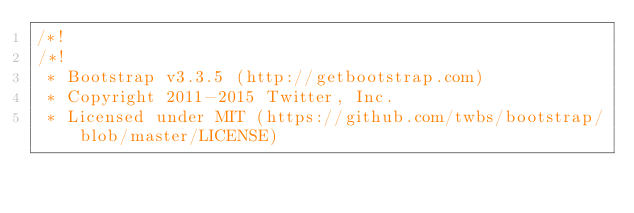<code> <loc_0><loc_0><loc_500><loc_500><_CSS_>/*!
/*!
 * Bootstrap v3.3.5 (http://getbootstrap.com)
 * Copyright 2011-2015 Twitter, Inc.
 * Licensed under MIT (https://github.com/twbs/bootstrap/blob/master/LICENSE)</code> 